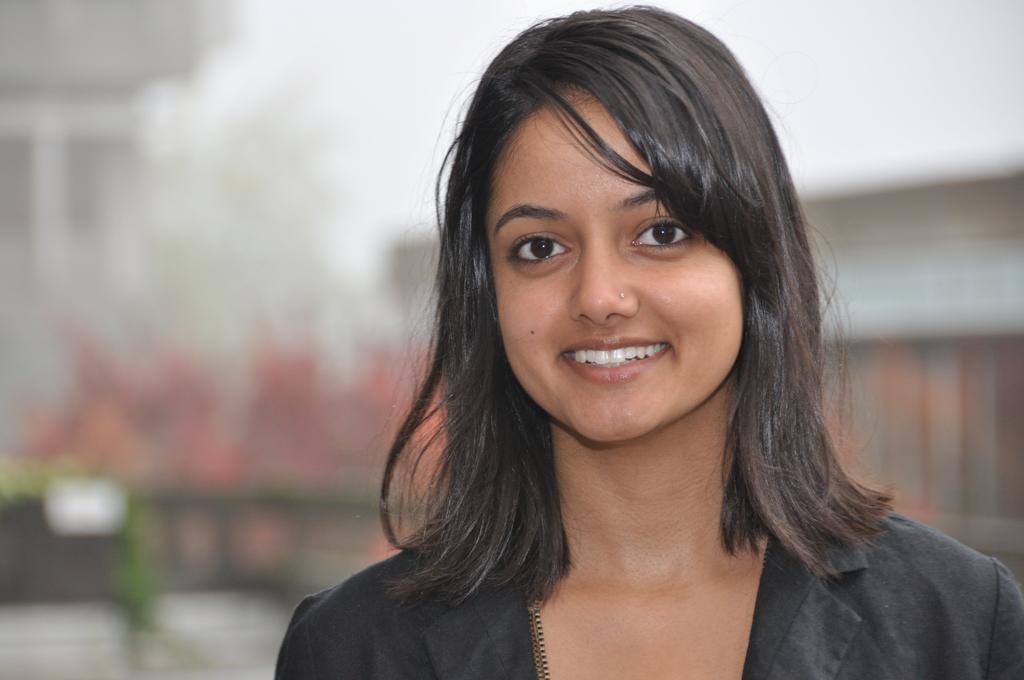Please provide a concise description of this image. Here we can see a woman and she is smiling. There is a blur background. 